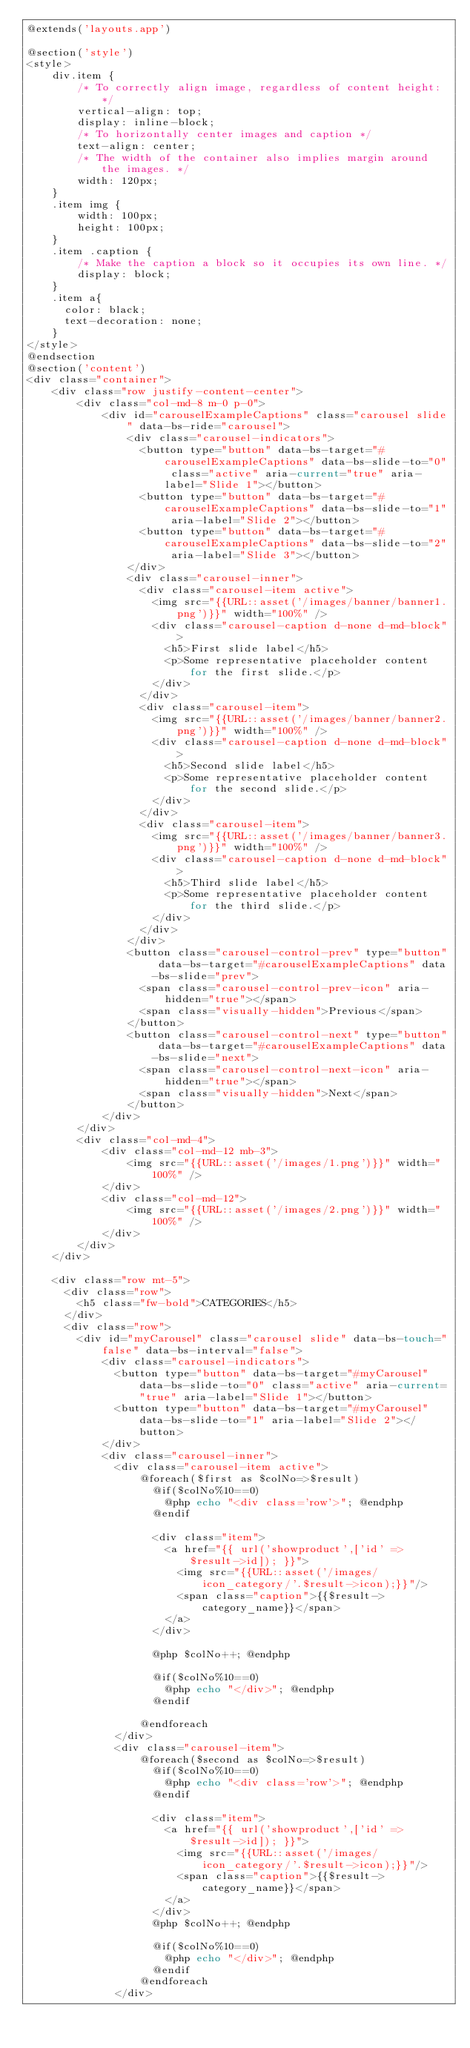Convert code to text. <code><loc_0><loc_0><loc_500><loc_500><_PHP_>@extends('layouts.app')

@section('style')
<style>
    div.item {
        /* To correctly align image, regardless of content height: */
        vertical-align: top;
        display: inline-block;
        /* To horizontally center images and caption */
        text-align: center;
        /* The width of the container also implies margin around the images. */
        width: 120px;
    }
    .item img {
        width: 100px;
        height: 100px;
    }
    .item .caption {
        /* Make the caption a block so it occupies its own line. */
        display: block;
    }
    .item a{
      color: black;
      text-decoration: none;
    }
</style>
@endsection
@section('content')
<div class="container">
    <div class="row justify-content-center">
        <div class="col-md-8 m-0 p-0">
            <div id="carouselExampleCaptions" class="carousel slide" data-bs-ride="carousel">
                <div class="carousel-indicators">
                  <button type="button" data-bs-target="#carouselExampleCaptions" data-bs-slide-to="0" class="active" aria-current="true" aria-label="Slide 1"></button>
                  <button type="button" data-bs-target="#carouselExampleCaptions" data-bs-slide-to="1" aria-label="Slide 2"></button>
                  <button type="button" data-bs-target="#carouselExampleCaptions" data-bs-slide-to="2" aria-label="Slide 3"></button>
                </div>
                <div class="carousel-inner">
                  <div class="carousel-item active">
                    <img src="{{URL::asset('/images/banner/banner1.png')}}" width="100%" />
                    <div class="carousel-caption d-none d-md-block">
                      <h5>First slide label</h5>
                      <p>Some representative placeholder content for the first slide.</p>
                    </div>
                  </div>
                  <div class="carousel-item">
                    <img src="{{URL::asset('/images/banner/banner2.png')}}" width="100%" />
                    <div class="carousel-caption d-none d-md-block">
                      <h5>Second slide label</h5>
                      <p>Some representative placeholder content for the second slide.</p>
                    </div>
                  </div>
                  <div class="carousel-item">
                    <img src="{{URL::asset('/images/banner/banner3.png')}}" width="100%" />
                    <div class="carousel-caption d-none d-md-block">
                      <h5>Third slide label</h5>
                      <p>Some representative placeholder content for the third slide.</p>
                    </div>
                  </div>
                </div>
                <button class="carousel-control-prev" type="button" data-bs-target="#carouselExampleCaptions" data-bs-slide="prev">
                  <span class="carousel-control-prev-icon" aria-hidden="true"></span>
                  <span class="visually-hidden">Previous</span>
                </button>
                <button class="carousel-control-next" type="button" data-bs-target="#carouselExampleCaptions" data-bs-slide="next">
                  <span class="carousel-control-next-icon" aria-hidden="true"></span>
                  <span class="visually-hidden">Next</span>
                </button>
            </div>
        </div>
        <div class="col-md-4">
            <div class="col-md-12 mb-3">
                <img src="{{URL::asset('/images/1.png')}}" width="100%" />
            </div>
            <div class="col-md-12">
                <img src="{{URL::asset('/images/2.png')}}" width="100%" />
            </div>
        </div>
    </div>

    <div class="row mt-5">
      <div class="row">
        <h5 class="fw-bold">CATEGORIES</h5>
      </div>
      <div class="row">
        <div id="myCarousel" class="carousel slide" data-bs-touch="false" data-bs-interval="false">
            <div class="carousel-indicators">
              <button type="button" data-bs-target="#myCarousel" data-bs-slide-to="0" class="active" aria-current="true" aria-label="Slide 1"></button>
              <button type="button" data-bs-target="#myCarousel" data-bs-slide-to="1" aria-label="Slide 2"></button>
            </div>
            <div class="carousel-inner">
              <div class="carousel-item active">
                  @foreach($first as $colNo=>$result)
                    @if($colNo%10==0)
                      @php echo "<div class='row'>"; @endphp
                    @endif
                    
                    <div class="item">
                      <a href="{{ url('showproduct',['id' => $result->id]); }}">
                        <img src="{{URL::asset('/images/icon_category/'.$result->icon);}}"/>
                        <span class="caption">{{$result->category_name}}</span>
                      </a>
                    </div>
                    
                    @php $colNo++; @endphp
      
                    @if($colNo%10==0)
                      @php echo "</div>"; @endphp
                    @endif
                    
                  @endforeach
              </div>
              <div class="carousel-item">
                  @foreach($second as $colNo=>$result)
                    @if($colNo%10==0)
                      @php echo "<div class='row'>"; @endphp
                    @endif
                    
                    <div class="item">
                      <a href="{{ url('showproduct',['id' => $result->id]); }}">
                        <img src="{{URL::asset('/images/icon_category/'.$result->icon);}}"/>
                        <span class="caption">{{$result->category_name}}</span>
                      </a>
                    </div>
                    @php $colNo++; @endphp
      
                    @if($colNo%10==0)
                      @php echo "</div>"; @endphp
                    @endif
                  @endforeach
              </div></code> 